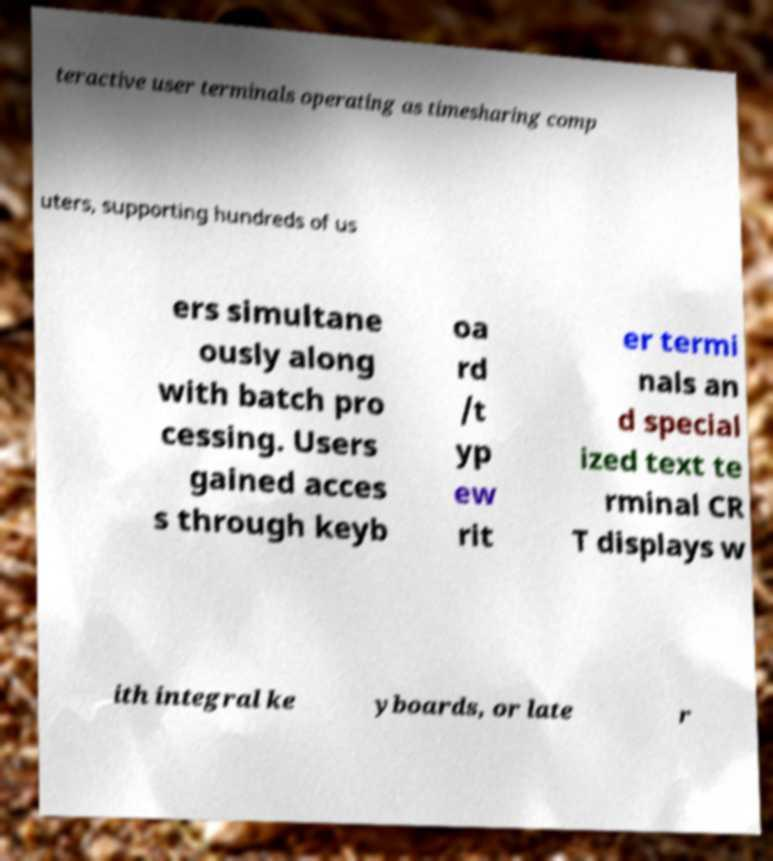Please read and relay the text visible in this image. What does it say? teractive user terminals operating as timesharing comp uters, supporting hundreds of us ers simultane ously along with batch pro cessing. Users gained acces s through keyb oa rd /t yp ew rit er termi nals an d special ized text te rminal CR T displays w ith integral ke yboards, or late r 